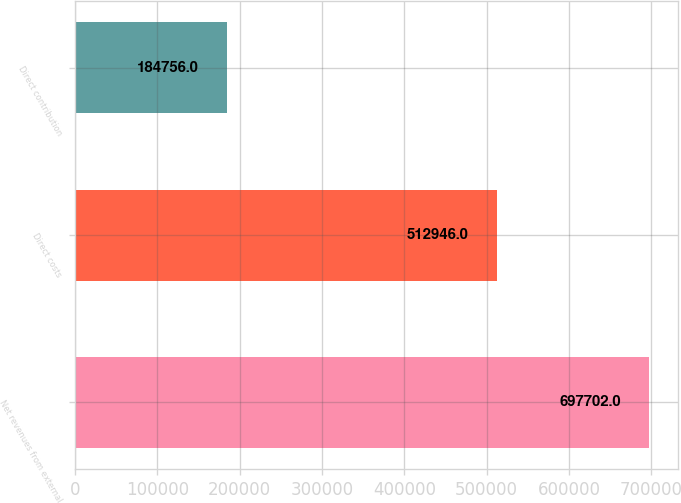<chart> <loc_0><loc_0><loc_500><loc_500><bar_chart><fcel>Net revenues from external<fcel>Direct costs<fcel>Direct contribution<nl><fcel>697702<fcel>512946<fcel>184756<nl></chart> 